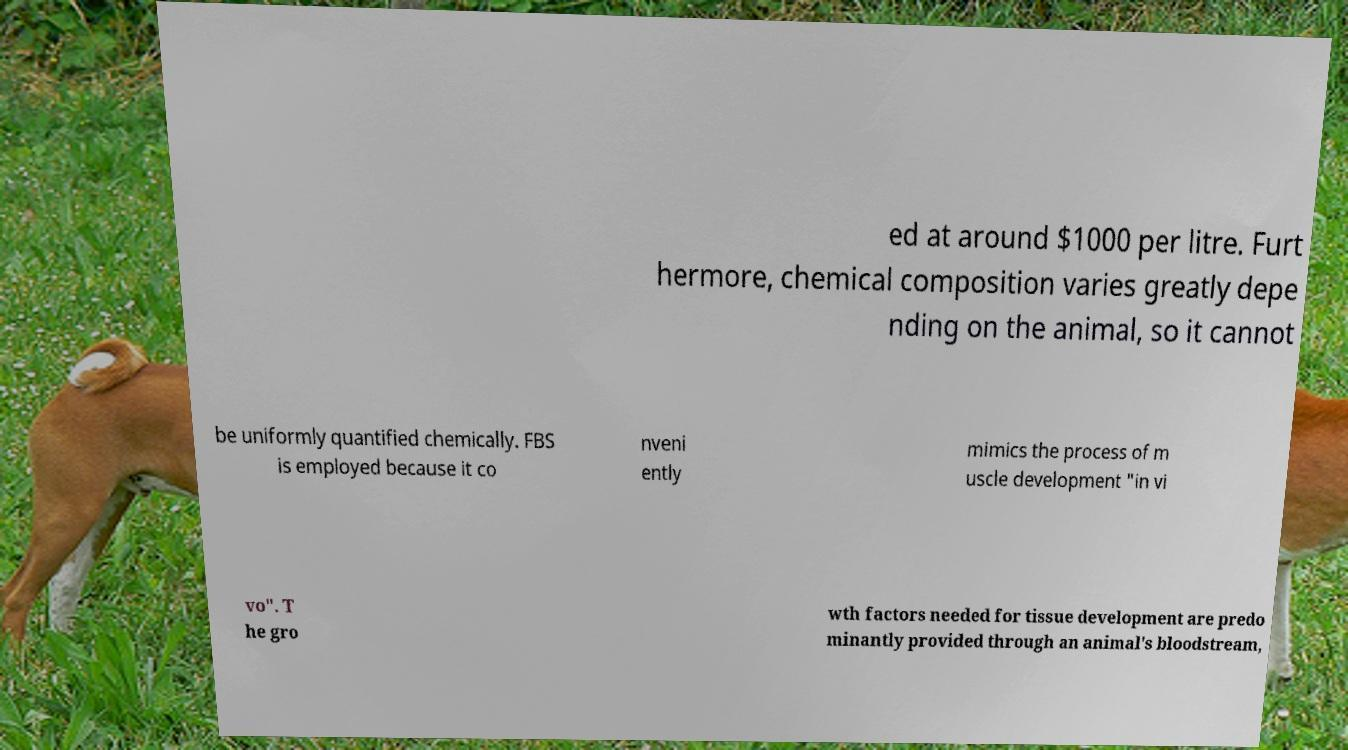Please identify and transcribe the text found in this image. ed at around $1000 per litre. Furt hermore, chemical composition varies greatly depe nding on the animal, so it cannot be uniformly quantified chemically. FBS is employed because it co nveni ently mimics the process of m uscle development "in vi vo". T he gro wth factors needed for tissue development are predo minantly provided through an animal's bloodstream, 